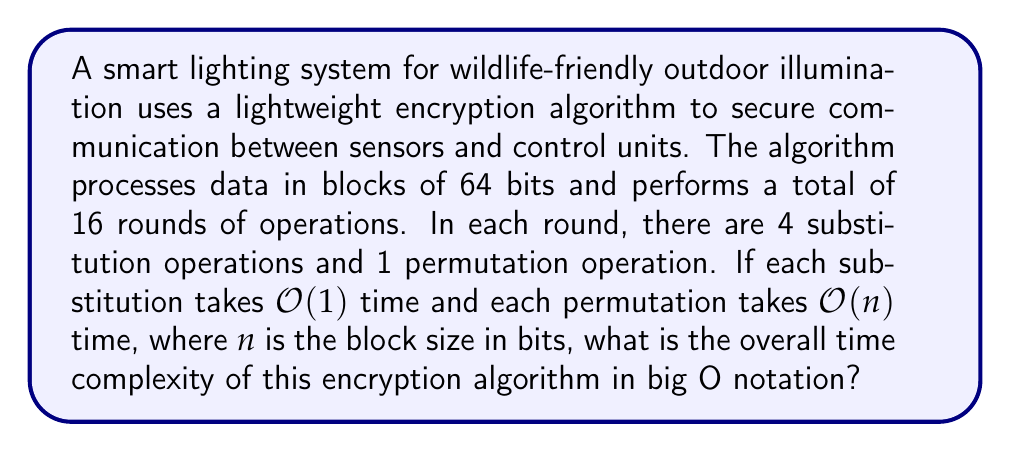What is the answer to this math problem? Let's break down the problem and analyze the complexity step-by-step:

1. Block size: $n = 64$ bits

2. Number of rounds: 16

3. Operations per round:
   - 4 substitutions: Each substitution is $O(1)$
   - 1 permutation: Each permutation is $O(n)$

4. Time complexity for one round:
   $$ T_{round} = 4 \cdot O(1) + 1 \cdot O(n) = O(n) $$

5. Total time complexity for all rounds:
   $$ T_{total} = 16 \cdot T_{round} = 16 \cdot O(n) = O(16n) $$

6. Simplify the complexity:
   In big O notation, we drop constant factors, so $O(16n)$ simplifies to $O(n)$

Therefore, the overall time complexity of the encryption algorithm is $O(n)$, where $n$ is the block size in bits.
Answer: $O(n)$ 